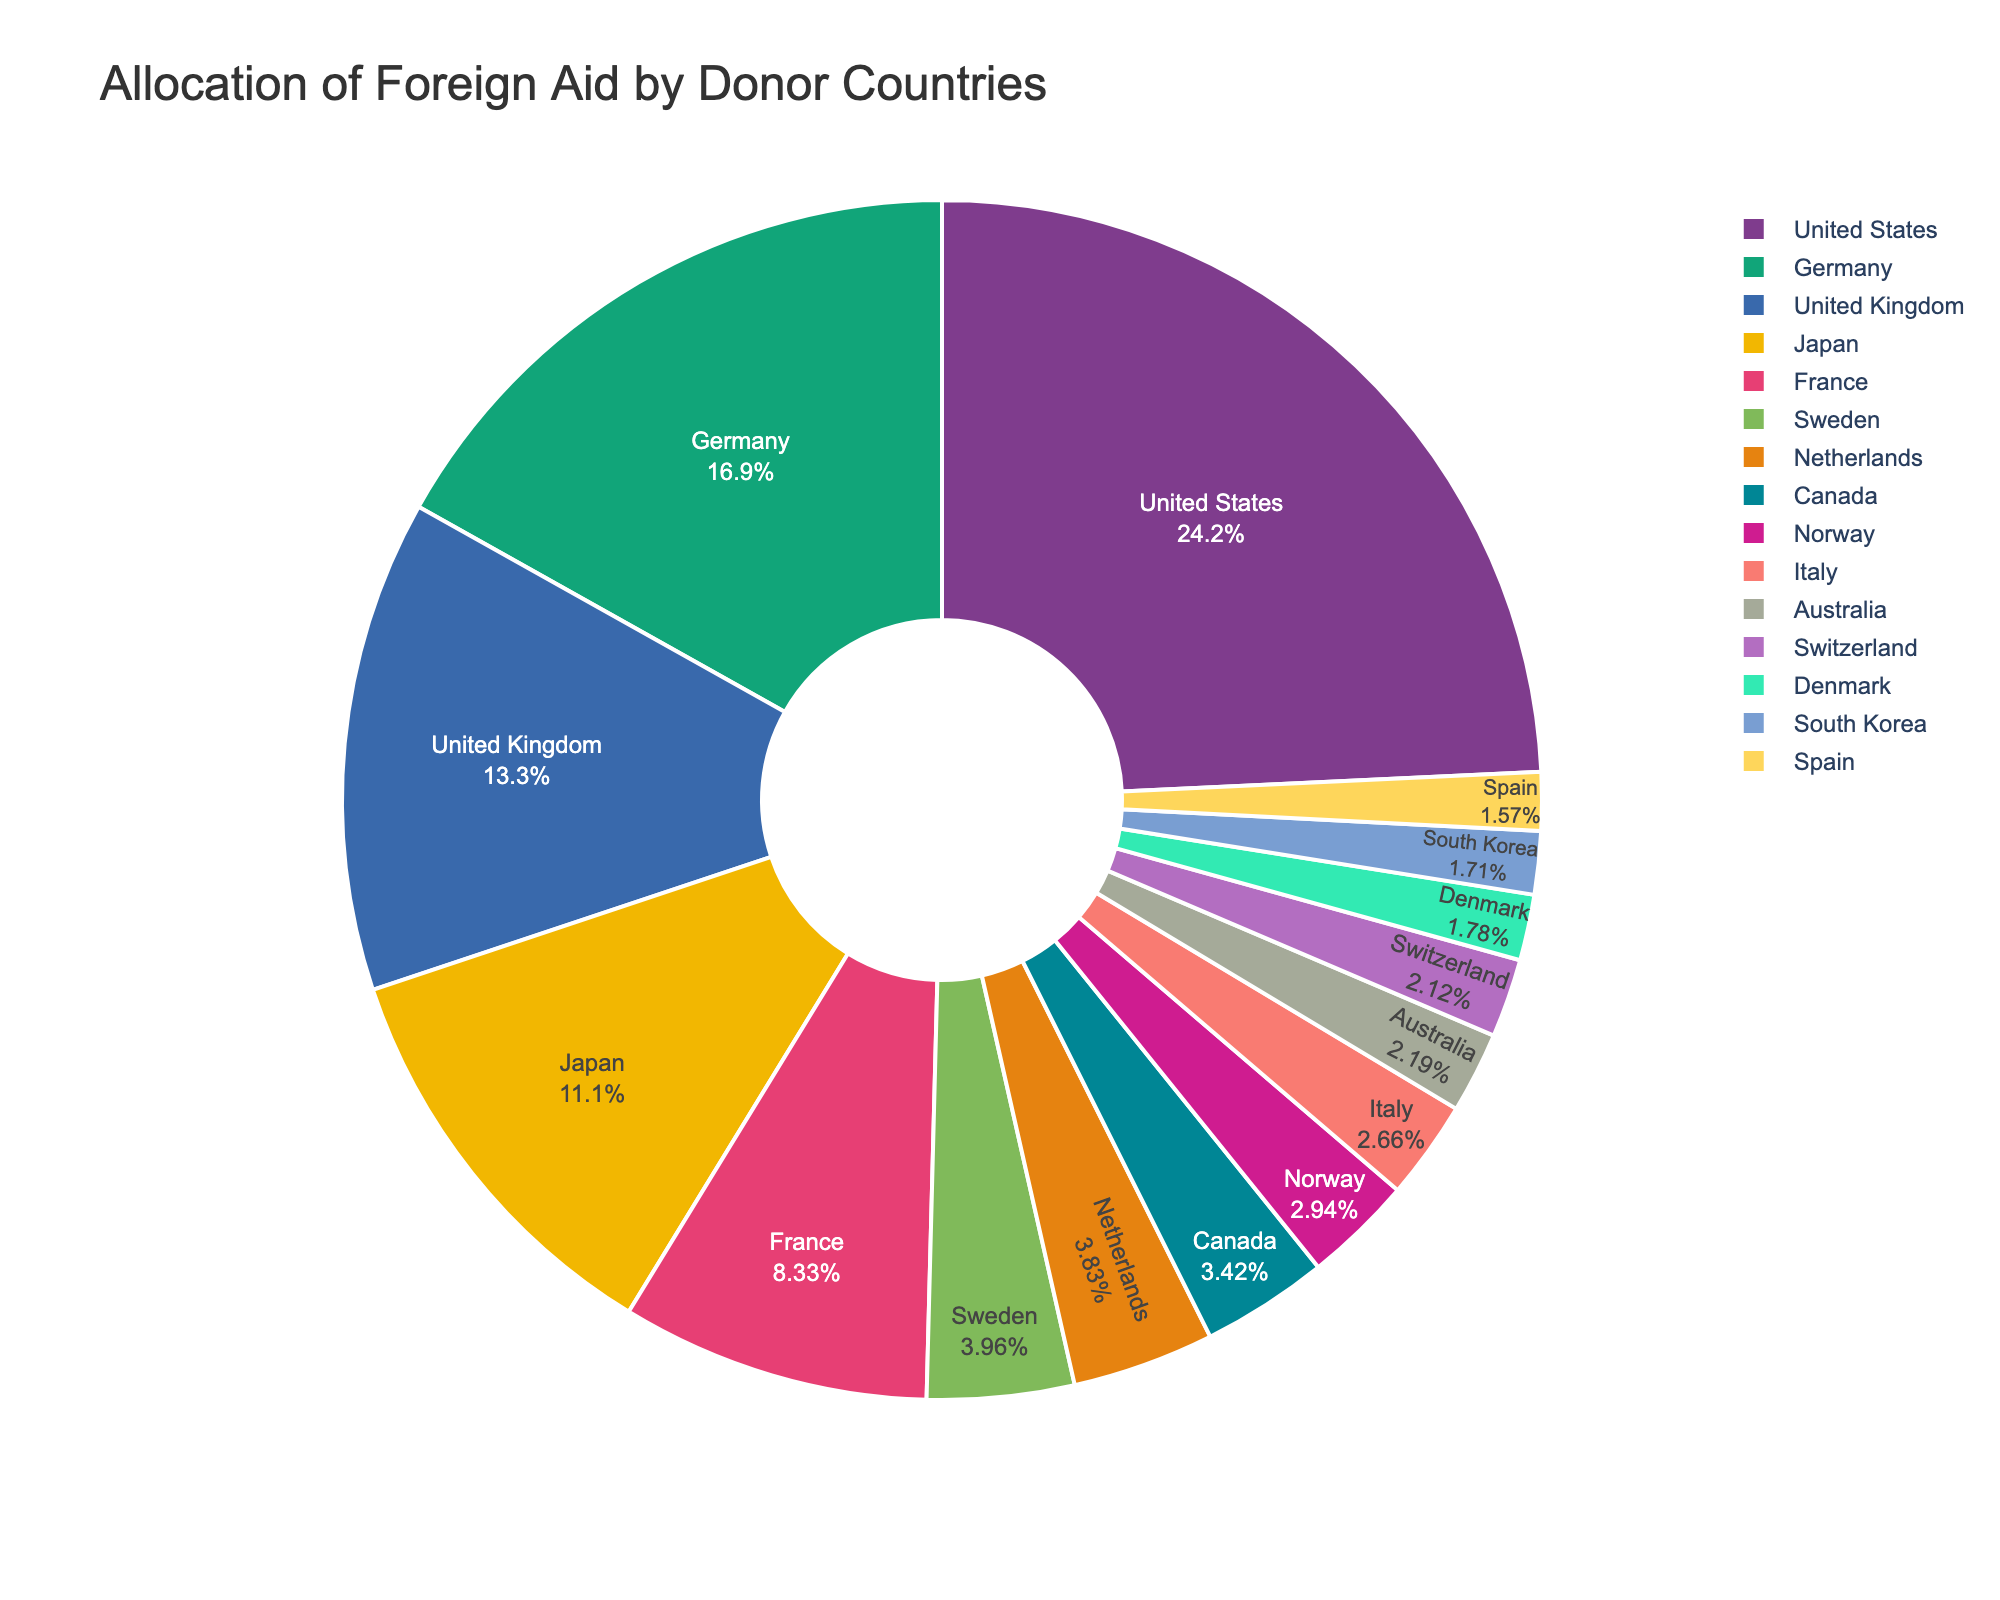Which country allocates the most foreign aid? By looking at the pie chart, find the country with the largest segment. The United States has the largest portion, indicating it allocates the most foreign aid.
Answer: United States What is the combined foreign aid allocation of Germany and France? Look at the segments representing Germany and France. Germany allocates 24.7 billion USD and France allocates 12.2 billion USD. Add these amounts together: 24.7 + 12.2 = 36.9 billion USD.
Answer: 36.9 billion USD Which country allocates more foreign aid, Japan or the United Kingdom? Compare the segments for Japan and the United Kingdom. Japan allocates 16.3 billion USD and the United Kingdom allocates 19.4 billion USD. The United Kingdom allocates more.
Answer: United Kingdom How much more foreign aid does the United States allocate compared to Canada? Find the segments for the United States and Canada. The United States allocates 35.5 billion USD and Canada allocates 5.0 billion USD. Subtract the two amounts: 35.5 - 5.0 = 30.5 billion USD.
Answer: 30.5 billion USD What percentage of the total foreign aid is allocated by Sweden? Find the segment for Sweden and look at its label, which shows Sweden's percentage of the total foreign aid. According to the pie chart, Sweden’s segment is 5.8 billion USD. Relate this value in percentage to the whole pie.
Answer: [A precise percentage should be indicated in the pie chart visually, but the exact value wasn't provided] If the five top donor countries (United States, Germany, United Kingdom, Japan, France) were grouped together, what would be their combined allocation? Find the allocations for the United States (35.5 billion USD), Germany (24.7 billion USD), United Kingdom (19.4 billion USD), Japan (16.3 billion USD), and France (12.2 billion USD). Add these amounts together: 35.5 + 24.7 + 19.4 + 16.3 + 12.2 = 108.1 billion USD.
Answer: 108.1 billion USD Which country has a larger foreign aid allocation: Norway or Italy? Compare the segments for Norway and Italy. Norway allocates 4.3 billion USD and Italy allocates 3.9 billion USD. Norway allocates more.
Answer: Norway What is the difference in foreign aid allocations between the country with the highest allocation and the country with the lowest allocation? Compare the segment for the country with the highest allocation (United States at 35.5 billion USD) and the country with the lowest allocation (Spain at 2.3 billion USD). Subtract the lower allocation from the higher allocation: 35.5 - 2.3 = 33.2 billion USD.
Answer: 33.2 billion USD By how much does the combined foreign aid allocation of the Scandinavian countries (Sweden, Norway, Denmark) exceed that of Canada? Find the allocations for Sweden (5.8 billion USD), Norway (4.3 billion USD), and Denmark (2.6 billion USD). Add these together: 5.8 + 4.3 + 2.6 = 12.7 billion USD. Then, find Canada’s allocation (5.0 billion USD) and subtract it from the combined Scandinavian total: 12.7 - 5.0 = 7.7 billion USD.
Answer: 7.7 billion USD 